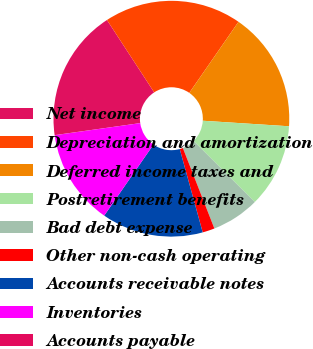Convert chart. <chart><loc_0><loc_0><loc_500><loc_500><pie_chart><fcel>Net income<fcel>Depreciation and amortization<fcel>Deferred income taxes and<fcel>Postretirement benefits<fcel>Bad debt expense<fcel>Other non-cash operating<fcel>Accounts receivable notes<fcel>Inventories<fcel>Accounts payable<nl><fcel>18.02%<fcel>18.84%<fcel>16.38%<fcel>11.47%<fcel>6.57%<fcel>1.66%<fcel>13.93%<fcel>13.11%<fcel>0.02%<nl></chart> 